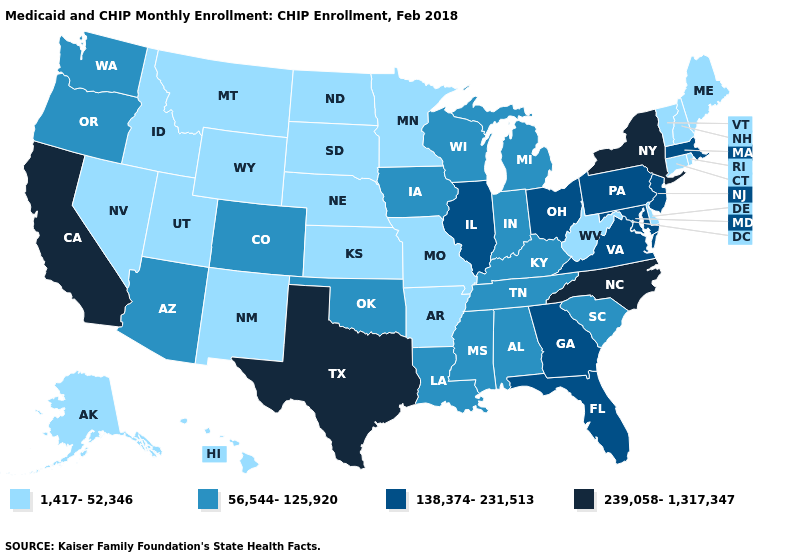How many symbols are there in the legend?
Be succinct. 4. Which states have the highest value in the USA?
Keep it brief. California, New York, North Carolina, Texas. What is the value of Oklahoma?
Give a very brief answer. 56,544-125,920. What is the value of Maryland?
Give a very brief answer. 138,374-231,513. Does Colorado have a lower value than Maryland?
Answer briefly. Yes. Which states have the highest value in the USA?
Answer briefly. California, New York, North Carolina, Texas. Does Nebraska have the lowest value in the USA?
Write a very short answer. Yes. What is the lowest value in the USA?
Quick response, please. 1,417-52,346. What is the value of South Dakota?
Write a very short answer. 1,417-52,346. What is the lowest value in the MidWest?
Keep it brief. 1,417-52,346. Does Connecticut have the lowest value in the Northeast?
Concise answer only. Yes. Name the states that have a value in the range 1,417-52,346?
Concise answer only. Alaska, Arkansas, Connecticut, Delaware, Hawaii, Idaho, Kansas, Maine, Minnesota, Missouri, Montana, Nebraska, Nevada, New Hampshire, New Mexico, North Dakota, Rhode Island, South Dakota, Utah, Vermont, West Virginia, Wyoming. What is the value of Kansas?
Short answer required. 1,417-52,346. What is the value of Wisconsin?
Keep it brief. 56,544-125,920. 